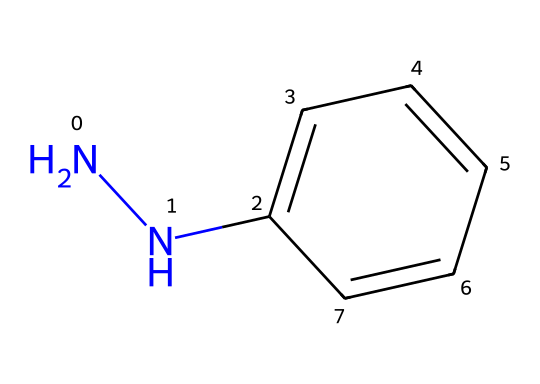What is the main functional group present in phenylhydrazine? The structure shows a hydrazine group, characterized by the presence of two nitrogen atoms (the NN part), which is a defining feature of hydrazines.
Answer: hydrazine How many hydrogen atoms are in phenylhydrazine? By counting the hydrogen atoms attached to the carbon and nitrogen atoms, there are a total of 10 hydrogen atoms in this structure.
Answer: 10 What type of bonding exists between carbon and nitrogen in phenylhydrazine? The connection between the carbon and nitrogen atoms involves covalent bonding, as they share electrons, evident from the structure.
Answer: covalent Which carbon atom is part of an aromatic ring in phenylhydrazine? The carbon atoms that make up the benzene ring (marked as c1ccccc1) belong to the aromatic structure, with one directly attached to the nitrogen.
Answer: aromatic carbon Why is phenylhydrazine considered an important reagent in pharmaceutical manufacturing? Phenylhydrazine is useful for synthesizing various pharmaceutical compounds due to its reactivity with carbonyl groups, allowing the formation of hydrazones.
Answer: reactivity How many rings are present in the structure of phenylhydrazine? The structure contains only one ring, which is the aromatic benzene ring.
Answer: one What role does phenylhydrazine play in the synthesis of other chemicals? Phenylhydrazine is primarily utilized as a building block in synthesizing other compounds, particularly those involving nitrogen functionalities.
Answer: building block 